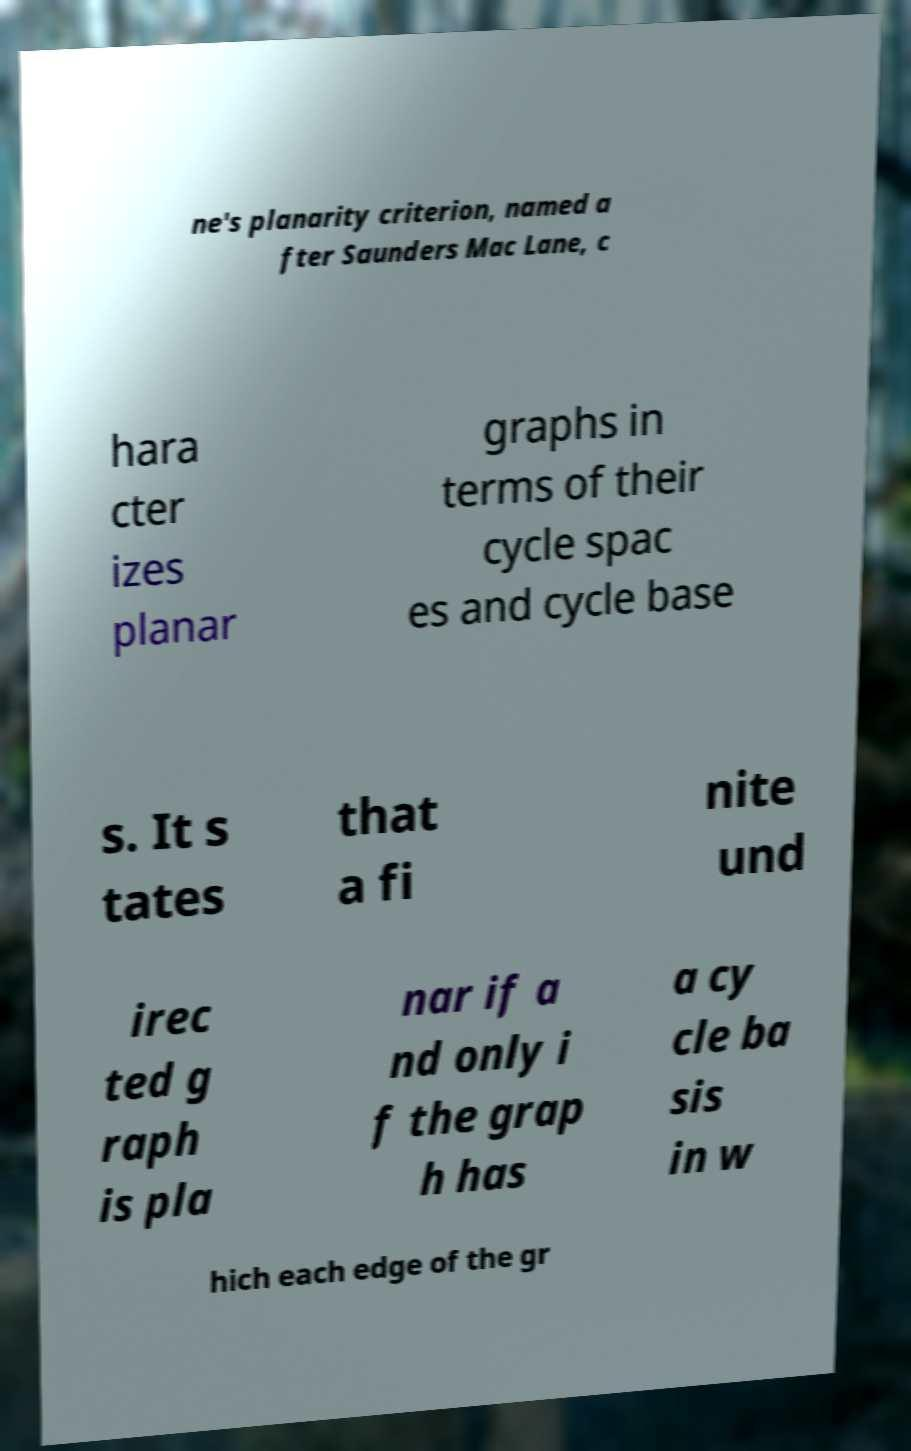There's text embedded in this image that I need extracted. Can you transcribe it verbatim? ne's planarity criterion, named a fter Saunders Mac Lane, c hara cter izes planar graphs in terms of their cycle spac es and cycle base s. It s tates that a fi nite und irec ted g raph is pla nar if a nd only i f the grap h has a cy cle ba sis in w hich each edge of the gr 